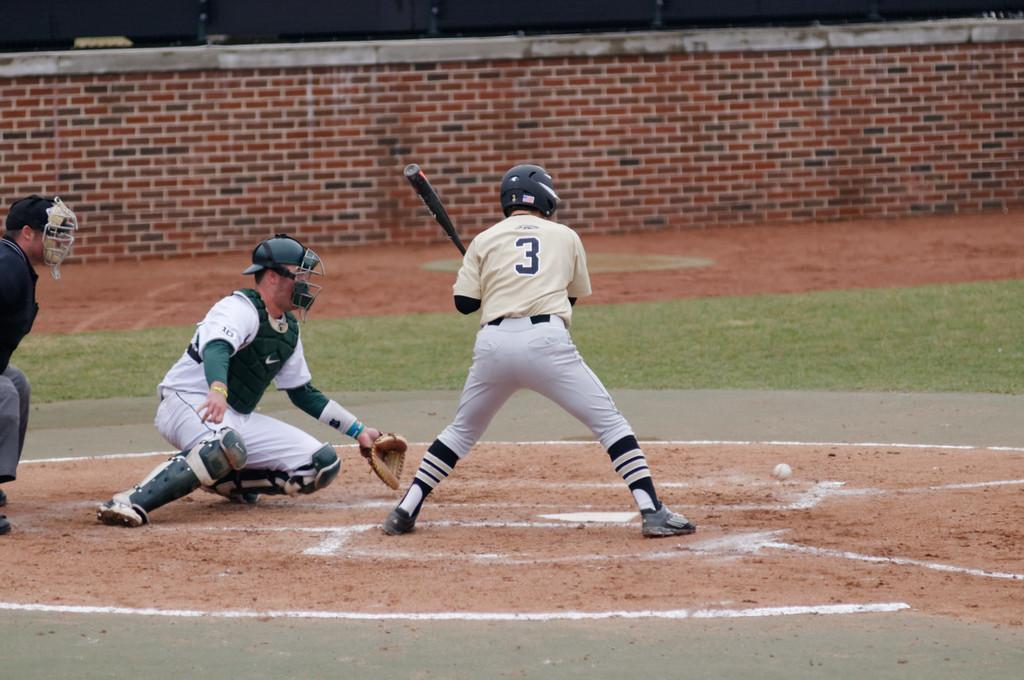Provide a one-sentence caption for the provided image. A baseball player with 3 on his uniform at bat. 